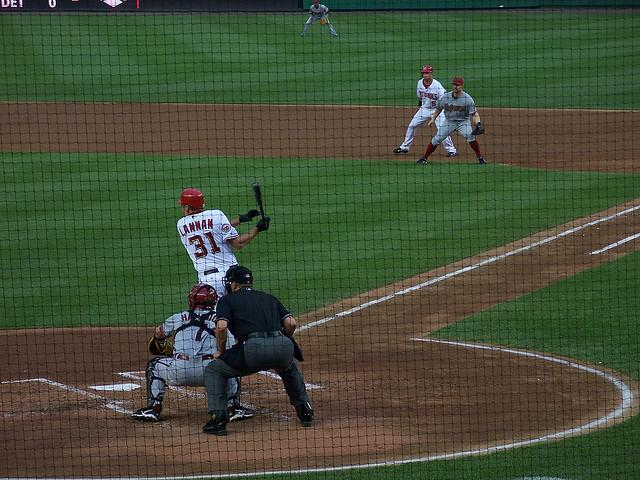What base is the player in white behind the grey suited player supposed to be on? Please explain your reasoning. first base. The batter would run from where he is which is home base to the very first white plate on our right before the ball is caught and he would be out. 